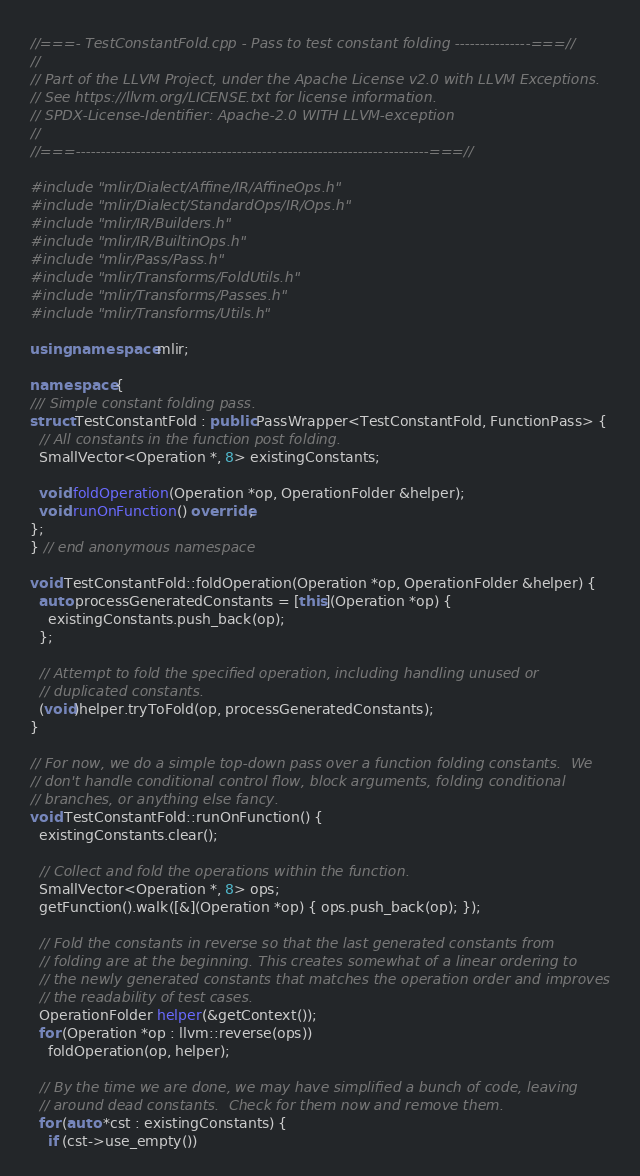<code> <loc_0><loc_0><loc_500><loc_500><_C++_>//===- TestConstantFold.cpp - Pass to test constant folding ---------------===//
//
// Part of the LLVM Project, under the Apache License v2.0 with LLVM Exceptions.
// See https://llvm.org/LICENSE.txt for license information.
// SPDX-License-Identifier: Apache-2.0 WITH LLVM-exception
//
//===----------------------------------------------------------------------===//

#include "mlir/Dialect/Affine/IR/AffineOps.h"
#include "mlir/Dialect/StandardOps/IR/Ops.h"
#include "mlir/IR/Builders.h"
#include "mlir/IR/BuiltinOps.h"
#include "mlir/Pass/Pass.h"
#include "mlir/Transforms/FoldUtils.h"
#include "mlir/Transforms/Passes.h"
#include "mlir/Transforms/Utils.h"

using namespace mlir;

namespace {
/// Simple constant folding pass.
struct TestConstantFold : public PassWrapper<TestConstantFold, FunctionPass> {
  // All constants in the function post folding.
  SmallVector<Operation *, 8> existingConstants;

  void foldOperation(Operation *op, OperationFolder &helper);
  void runOnFunction() override;
};
} // end anonymous namespace

void TestConstantFold::foldOperation(Operation *op, OperationFolder &helper) {
  auto processGeneratedConstants = [this](Operation *op) {
    existingConstants.push_back(op);
  };

  // Attempt to fold the specified operation, including handling unused or
  // duplicated constants.
  (void)helper.tryToFold(op, processGeneratedConstants);
}

// For now, we do a simple top-down pass over a function folding constants.  We
// don't handle conditional control flow, block arguments, folding conditional
// branches, or anything else fancy.
void TestConstantFold::runOnFunction() {
  existingConstants.clear();

  // Collect and fold the operations within the function.
  SmallVector<Operation *, 8> ops;
  getFunction().walk([&](Operation *op) { ops.push_back(op); });

  // Fold the constants in reverse so that the last generated constants from
  // folding are at the beginning. This creates somewhat of a linear ordering to
  // the newly generated constants that matches the operation order and improves
  // the readability of test cases.
  OperationFolder helper(&getContext());
  for (Operation *op : llvm::reverse(ops))
    foldOperation(op, helper);

  // By the time we are done, we may have simplified a bunch of code, leaving
  // around dead constants.  Check for them now and remove them.
  for (auto *cst : existingConstants) {
    if (cst->use_empty())</code> 